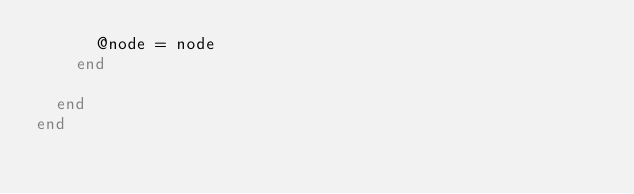Convert code to text. <code><loc_0><loc_0><loc_500><loc_500><_Ruby_>      @node = node
    end

  end
end
</code> 